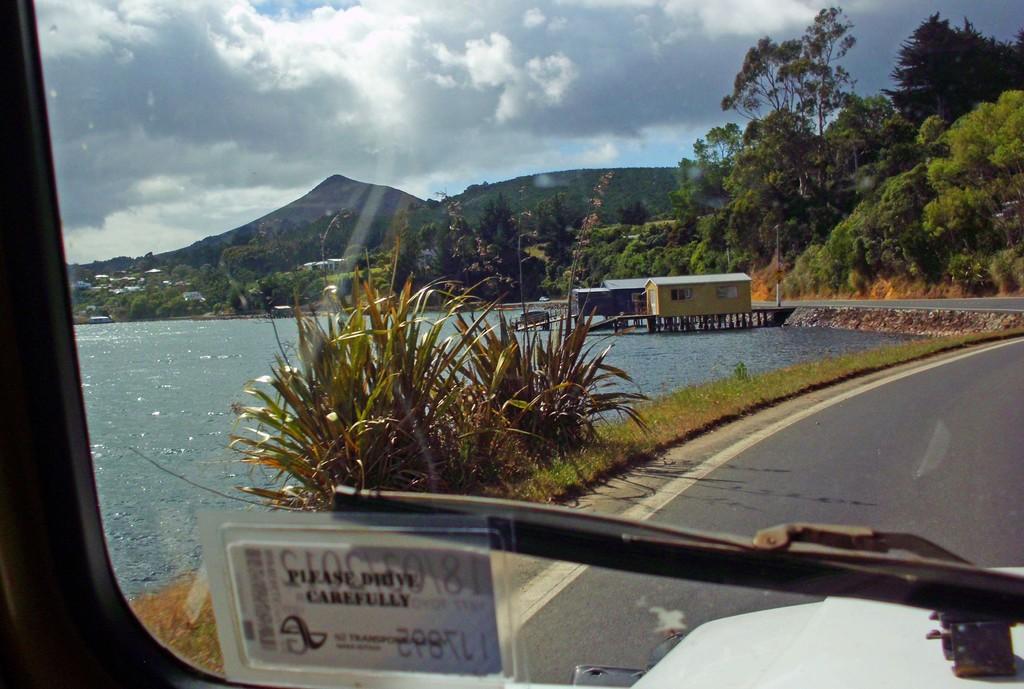In one or two sentences, can you explain what this image depicts? In this image I see a the wiper, road, plants, water, 2 houses over here and a lot of trees and mountains and in the background I see the sky is a bit cloudy. 